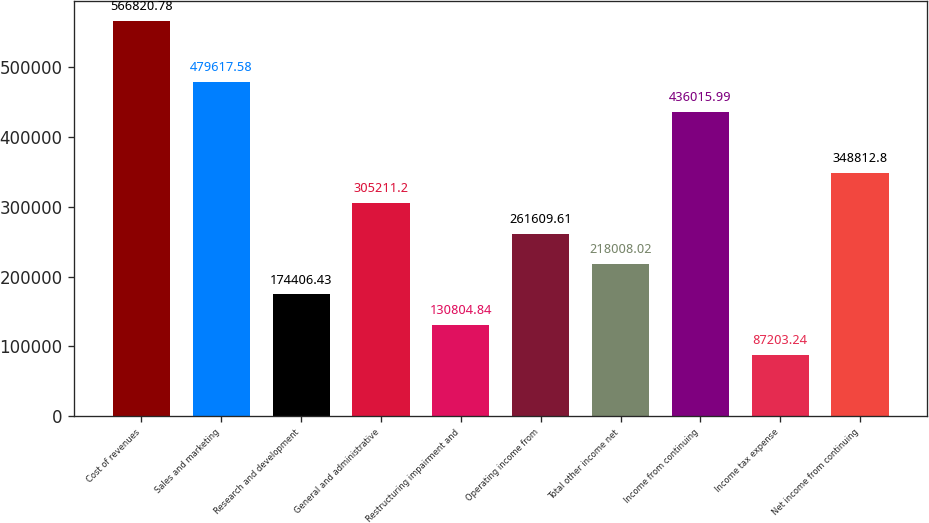<chart> <loc_0><loc_0><loc_500><loc_500><bar_chart><fcel>Cost of revenues<fcel>Sales and marketing<fcel>Research and development<fcel>General and administrative<fcel>Restructuring impairment and<fcel>Operating income from<fcel>Total other income net<fcel>Income from continuing<fcel>Income tax expense<fcel>Net income from continuing<nl><fcel>566821<fcel>479618<fcel>174406<fcel>305211<fcel>130805<fcel>261610<fcel>218008<fcel>436016<fcel>87203.2<fcel>348813<nl></chart> 